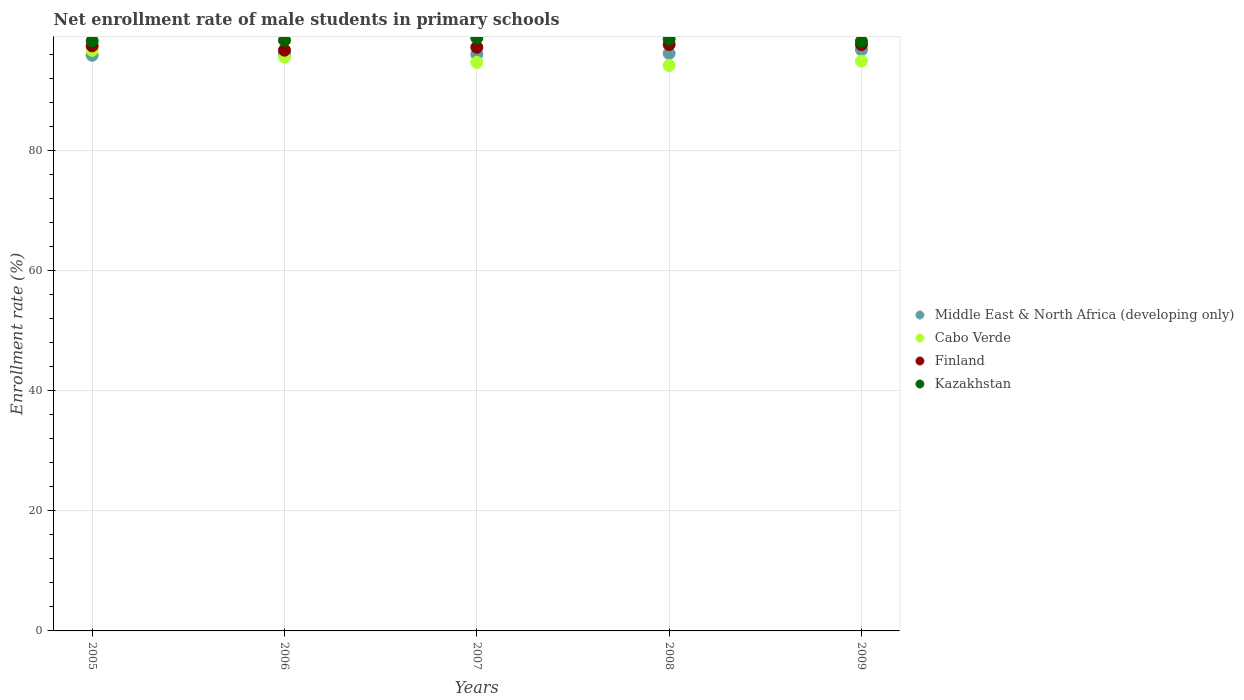What is the net enrollment rate of male students in primary schools in Finland in 2009?
Offer a terse response. 97.64. Across all years, what is the maximum net enrollment rate of male students in primary schools in Kazakhstan?
Your answer should be very brief. 98.74. Across all years, what is the minimum net enrollment rate of male students in primary schools in Kazakhstan?
Make the answer very short. 98.2. What is the total net enrollment rate of male students in primary schools in Cabo Verde in the graph?
Keep it short and to the point. 475.93. What is the difference between the net enrollment rate of male students in primary schools in Kazakhstan in 2006 and that in 2008?
Your response must be concise. -0.2. What is the difference between the net enrollment rate of male students in primary schools in Cabo Verde in 2008 and the net enrollment rate of male students in primary schools in Middle East & North Africa (developing only) in 2007?
Your response must be concise. -1.85. What is the average net enrollment rate of male students in primary schools in Finland per year?
Ensure brevity in your answer.  97.32. In the year 2007, what is the difference between the net enrollment rate of male students in primary schools in Middle East & North Africa (developing only) and net enrollment rate of male students in primary schools in Finland?
Your answer should be very brief. -1.18. In how many years, is the net enrollment rate of male students in primary schools in Cabo Verde greater than 40 %?
Your answer should be very brief. 5. What is the ratio of the net enrollment rate of male students in primary schools in Finland in 2008 to that in 2009?
Give a very brief answer. 1. What is the difference between the highest and the second highest net enrollment rate of male students in primary schools in Kazakhstan?
Provide a short and direct response. 0.19. What is the difference between the highest and the lowest net enrollment rate of male students in primary schools in Cabo Verde?
Offer a very short reply. 2.53. Is it the case that in every year, the sum of the net enrollment rate of male students in primary schools in Cabo Verde and net enrollment rate of male students in primary schools in Middle East & North Africa (developing only)  is greater than the sum of net enrollment rate of male students in primary schools in Finland and net enrollment rate of male students in primary schools in Kazakhstan?
Your response must be concise. No. Is the net enrollment rate of male students in primary schools in Kazakhstan strictly greater than the net enrollment rate of male students in primary schools in Finland over the years?
Provide a succinct answer. Yes. How many years are there in the graph?
Ensure brevity in your answer.  5. Are the values on the major ticks of Y-axis written in scientific E-notation?
Make the answer very short. No. Does the graph contain any zero values?
Your response must be concise. No. Does the graph contain grids?
Offer a terse response. Yes. What is the title of the graph?
Ensure brevity in your answer.  Net enrollment rate of male students in primary schools. Does "Lao PDR" appear as one of the legend labels in the graph?
Your answer should be compact. No. What is the label or title of the X-axis?
Offer a terse response. Years. What is the label or title of the Y-axis?
Your response must be concise. Enrollment rate (%). What is the Enrollment rate (%) of Middle East & North Africa (developing only) in 2005?
Your answer should be compact. 95.85. What is the Enrollment rate (%) in Cabo Verde in 2005?
Make the answer very short. 96.68. What is the Enrollment rate (%) in Finland in 2005?
Offer a very short reply. 97.43. What is the Enrollment rate (%) of Kazakhstan in 2005?
Offer a terse response. 98.26. What is the Enrollment rate (%) of Middle East & North Africa (developing only) in 2006?
Provide a short and direct response. 96.03. What is the Enrollment rate (%) in Cabo Verde in 2006?
Your answer should be very brief. 95.53. What is the Enrollment rate (%) of Finland in 2006?
Make the answer very short. 96.71. What is the Enrollment rate (%) in Kazakhstan in 2006?
Your answer should be very brief. 98.36. What is the Enrollment rate (%) of Middle East & North Africa (developing only) in 2007?
Make the answer very short. 96. What is the Enrollment rate (%) in Cabo Verde in 2007?
Offer a very short reply. 94.67. What is the Enrollment rate (%) of Finland in 2007?
Offer a very short reply. 97.19. What is the Enrollment rate (%) of Kazakhstan in 2007?
Give a very brief answer. 98.74. What is the Enrollment rate (%) of Middle East & North Africa (developing only) in 2008?
Keep it short and to the point. 96.17. What is the Enrollment rate (%) of Cabo Verde in 2008?
Offer a terse response. 94.15. What is the Enrollment rate (%) in Finland in 2008?
Provide a short and direct response. 97.65. What is the Enrollment rate (%) in Kazakhstan in 2008?
Make the answer very short. 98.56. What is the Enrollment rate (%) of Middle East & North Africa (developing only) in 2009?
Offer a terse response. 96.76. What is the Enrollment rate (%) of Cabo Verde in 2009?
Your answer should be compact. 94.89. What is the Enrollment rate (%) in Finland in 2009?
Give a very brief answer. 97.64. What is the Enrollment rate (%) in Kazakhstan in 2009?
Offer a terse response. 98.2. Across all years, what is the maximum Enrollment rate (%) in Middle East & North Africa (developing only)?
Your answer should be compact. 96.76. Across all years, what is the maximum Enrollment rate (%) in Cabo Verde?
Your response must be concise. 96.68. Across all years, what is the maximum Enrollment rate (%) in Finland?
Keep it short and to the point. 97.65. Across all years, what is the maximum Enrollment rate (%) of Kazakhstan?
Offer a terse response. 98.74. Across all years, what is the minimum Enrollment rate (%) in Middle East & North Africa (developing only)?
Your answer should be compact. 95.85. Across all years, what is the minimum Enrollment rate (%) of Cabo Verde?
Your answer should be very brief. 94.15. Across all years, what is the minimum Enrollment rate (%) of Finland?
Provide a succinct answer. 96.71. Across all years, what is the minimum Enrollment rate (%) of Kazakhstan?
Your answer should be very brief. 98.2. What is the total Enrollment rate (%) in Middle East & North Africa (developing only) in the graph?
Your answer should be compact. 480.81. What is the total Enrollment rate (%) in Cabo Verde in the graph?
Keep it short and to the point. 475.93. What is the total Enrollment rate (%) of Finland in the graph?
Offer a very short reply. 486.61. What is the total Enrollment rate (%) of Kazakhstan in the graph?
Your answer should be very brief. 492.12. What is the difference between the Enrollment rate (%) in Middle East & North Africa (developing only) in 2005 and that in 2006?
Provide a succinct answer. -0.17. What is the difference between the Enrollment rate (%) in Cabo Verde in 2005 and that in 2006?
Provide a short and direct response. 1.15. What is the difference between the Enrollment rate (%) in Finland in 2005 and that in 2006?
Make the answer very short. 0.72. What is the difference between the Enrollment rate (%) of Kazakhstan in 2005 and that in 2006?
Offer a terse response. -0.1. What is the difference between the Enrollment rate (%) of Middle East & North Africa (developing only) in 2005 and that in 2007?
Your answer should be very brief. -0.15. What is the difference between the Enrollment rate (%) of Cabo Verde in 2005 and that in 2007?
Offer a very short reply. 2.01. What is the difference between the Enrollment rate (%) of Finland in 2005 and that in 2007?
Give a very brief answer. 0.24. What is the difference between the Enrollment rate (%) of Kazakhstan in 2005 and that in 2007?
Your answer should be compact. -0.48. What is the difference between the Enrollment rate (%) of Middle East & North Africa (developing only) in 2005 and that in 2008?
Offer a terse response. -0.31. What is the difference between the Enrollment rate (%) of Cabo Verde in 2005 and that in 2008?
Offer a terse response. 2.53. What is the difference between the Enrollment rate (%) in Finland in 2005 and that in 2008?
Make the answer very short. -0.22. What is the difference between the Enrollment rate (%) of Kazakhstan in 2005 and that in 2008?
Your response must be concise. -0.3. What is the difference between the Enrollment rate (%) in Middle East & North Africa (developing only) in 2005 and that in 2009?
Your answer should be very brief. -0.91. What is the difference between the Enrollment rate (%) in Cabo Verde in 2005 and that in 2009?
Ensure brevity in your answer.  1.79. What is the difference between the Enrollment rate (%) in Finland in 2005 and that in 2009?
Keep it short and to the point. -0.21. What is the difference between the Enrollment rate (%) of Kazakhstan in 2005 and that in 2009?
Offer a terse response. 0.06. What is the difference between the Enrollment rate (%) of Middle East & North Africa (developing only) in 2006 and that in 2007?
Ensure brevity in your answer.  0.02. What is the difference between the Enrollment rate (%) of Cabo Verde in 2006 and that in 2007?
Make the answer very short. 0.86. What is the difference between the Enrollment rate (%) of Finland in 2006 and that in 2007?
Your answer should be very brief. -0.48. What is the difference between the Enrollment rate (%) in Kazakhstan in 2006 and that in 2007?
Offer a terse response. -0.38. What is the difference between the Enrollment rate (%) in Middle East & North Africa (developing only) in 2006 and that in 2008?
Your answer should be very brief. -0.14. What is the difference between the Enrollment rate (%) in Cabo Verde in 2006 and that in 2008?
Offer a very short reply. 1.38. What is the difference between the Enrollment rate (%) of Finland in 2006 and that in 2008?
Give a very brief answer. -0.94. What is the difference between the Enrollment rate (%) of Kazakhstan in 2006 and that in 2008?
Ensure brevity in your answer.  -0.2. What is the difference between the Enrollment rate (%) in Middle East & North Africa (developing only) in 2006 and that in 2009?
Offer a very short reply. -0.73. What is the difference between the Enrollment rate (%) of Cabo Verde in 2006 and that in 2009?
Provide a succinct answer. 0.64. What is the difference between the Enrollment rate (%) in Finland in 2006 and that in 2009?
Your answer should be very brief. -0.93. What is the difference between the Enrollment rate (%) of Kazakhstan in 2006 and that in 2009?
Your answer should be compact. 0.16. What is the difference between the Enrollment rate (%) in Middle East & North Africa (developing only) in 2007 and that in 2008?
Offer a terse response. -0.16. What is the difference between the Enrollment rate (%) in Cabo Verde in 2007 and that in 2008?
Offer a terse response. 0.52. What is the difference between the Enrollment rate (%) of Finland in 2007 and that in 2008?
Your response must be concise. -0.47. What is the difference between the Enrollment rate (%) in Kazakhstan in 2007 and that in 2008?
Your response must be concise. 0.19. What is the difference between the Enrollment rate (%) of Middle East & North Africa (developing only) in 2007 and that in 2009?
Your answer should be very brief. -0.76. What is the difference between the Enrollment rate (%) of Cabo Verde in 2007 and that in 2009?
Make the answer very short. -0.22. What is the difference between the Enrollment rate (%) in Finland in 2007 and that in 2009?
Offer a terse response. -0.45. What is the difference between the Enrollment rate (%) of Kazakhstan in 2007 and that in 2009?
Give a very brief answer. 0.54. What is the difference between the Enrollment rate (%) in Middle East & North Africa (developing only) in 2008 and that in 2009?
Provide a succinct answer. -0.59. What is the difference between the Enrollment rate (%) of Cabo Verde in 2008 and that in 2009?
Ensure brevity in your answer.  -0.74. What is the difference between the Enrollment rate (%) in Finland in 2008 and that in 2009?
Provide a short and direct response. 0.01. What is the difference between the Enrollment rate (%) of Kazakhstan in 2008 and that in 2009?
Offer a very short reply. 0.36. What is the difference between the Enrollment rate (%) in Middle East & North Africa (developing only) in 2005 and the Enrollment rate (%) in Cabo Verde in 2006?
Provide a succinct answer. 0.32. What is the difference between the Enrollment rate (%) in Middle East & North Africa (developing only) in 2005 and the Enrollment rate (%) in Finland in 2006?
Provide a short and direct response. -0.86. What is the difference between the Enrollment rate (%) in Middle East & North Africa (developing only) in 2005 and the Enrollment rate (%) in Kazakhstan in 2006?
Your response must be concise. -2.51. What is the difference between the Enrollment rate (%) of Cabo Verde in 2005 and the Enrollment rate (%) of Finland in 2006?
Offer a terse response. -0.03. What is the difference between the Enrollment rate (%) of Cabo Verde in 2005 and the Enrollment rate (%) of Kazakhstan in 2006?
Give a very brief answer. -1.68. What is the difference between the Enrollment rate (%) of Finland in 2005 and the Enrollment rate (%) of Kazakhstan in 2006?
Your response must be concise. -0.93. What is the difference between the Enrollment rate (%) in Middle East & North Africa (developing only) in 2005 and the Enrollment rate (%) in Cabo Verde in 2007?
Your response must be concise. 1.18. What is the difference between the Enrollment rate (%) in Middle East & North Africa (developing only) in 2005 and the Enrollment rate (%) in Finland in 2007?
Your answer should be very brief. -1.33. What is the difference between the Enrollment rate (%) in Middle East & North Africa (developing only) in 2005 and the Enrollment rate (%) in Kazakhstan in 2007?
Provide a short and direct response. -2.89. What is the difference between the Enrollment rate (%) in Cabo Verde in 2005 and the Enrollment rate (%) in Finland in 2007?
Provide a succinct answer. -0.5. What is the difference between the Enrollment rate (%) of Cabo Verde in 2005 and the Enrollment rate (%) of Kazakhstan in 2007?
Offer a terse response. -2.06. What is the difference between the Enrollment rate (%) of Finland in 2005 and the Enrollment rate (%) of Kazakhstan in 2007?
Make the answer very short. -1.31. What is the difference between the Enrollment rate (%) in Middle East & North Africa (developing only) in 2005 and the Enrollment rate (%) in Cabo Verde in 2008?
Ensure brevity in your answer.  1.7. What is the difference between the Enrollment rate (%) in Middle East & North Africa (developing only) in 2005 and the Enrollment rate (%) in Finland in 2008?
Offer a terse response. -1.8. What is the difference between the Enrollment rate (%) of Middle East & North Africa (developing only) in 2005 and the Enrollment rate (%) of Kazakhstan in 2008?
Ensure brevity in your answer.  -2.7. What is the difference between the Enrollment rate (%) in Cabo Verde in 2005 and the Enrollment rate (%) in Finland in 2008?
Provide a short and direct response. -0.97. What is the difference between the Enrollment rate (%) of Cabo Verde in 2005 and the Enrollment rate (%) of Kazakhstan in 2008?
Offer a terse response. -1.88. What is the difference between the Enrollment rate (%) of Finland in 2005 and the Enrollment rate (%) of Kazakhstan in 2008?
Ensure brevity in your answer.  -1.13. What is the difference between the Enrollment rate (%) of Middle East & North Africa (developing only) in 2005 and the Enrollment rate (%) of Cabo Verde in 2009?
Give a very brief answer. 0.96. What is the difference between the Enrollment rate (%) of Middle East & North Africa (developing only) in 2005 and the Enrollment rate (%) of Finland in 2009?
Your answer should be compact. -1.78. What is the difference between the Enrollment rate (%) in Middle East & North Africa (developing only) in 2005 and the Enrollment rate (%) in Kazakhstan in 2009?
Your answer should be compact. -2.35. What is the difference between the Enrollment rate (%) of Cabo Verde in 2005 and the Enrollment rate (%) of Finland in 2009?
Your answer should be very brief. -0.96. What is the difference between the Enrollment rate (%) of Cabo Verde in 2005 and the Enrollment rate (%) of Kazakhstan in 2009?
Keep it short and to the point. -1.52. What is the difference between the Enrollment rate (%) of Finland in 2005 and the Enrollment rate (%) of Kazakhstan in 2009?
Ensure brevity in your answer.  -0.77. What is the difference between the Enrollment rate (%) of Middle East & North Africa (developing only) in 2006 and the Enrollment rate (%) of Cabo Verde in 2007?
Give a very brief answer. 1.36. What is the difference between the Enrollment rate (%) of Middle East & North Africa (developing only) in 2006 and the Enrollment rate (%) of Finland in 2007?
Keep it short and to the point. -1.16. What is the difference between the Enrollment rate (%) in Middle East & North Africa (developing only) in 2006 and the Enrollment rate (%) in Kazakhstan in 2007?
Your answer should be very brief. -2.72. What is the difference between the Enrollment rate (%) in Cabo Verde in 2006 and the Enrollment rate (%) in Finland in 2007?
Your answer should be compact. -1.65. What is the difference between the Enrollment rate (%) of Cabo Verde in 2006 and the Enrollment rate (%) of Kazakhstan in 2007?
Ensure brevity in your answer.  -3.21. What is the difference between the Enrollment rate (%) of Finland in 2006 and the Enrollment rate (%) of Kazakhstan in 2007?
Your response must be concise. -2.03. What is the difference between the Enrollment rate (%) of Middle East & North Africa (developing only) in 2006 and the Enrollment rate (%) of Cabo Verde in 2008?
Offer a very short reply. 1.87. What is the difference between the Enrollment rate (%) of Middle East & North Africa (developing only) in 2006 and the Enrollment rate (%) of Finland in 2008?
Give a very brief answer. -1.62. What is the difference between the Enrollment rate (%) in Middle East & North Africa (developing only) in 2006 and the Enrollment rate (%) in Kazakhstan in 2008?
Give a very brief answer. -2.53. What is the difference between the Enrollment rate (%) in Cabo Verde in 2006 and the Enrollment rate (%) in Finland in 2008?
Give a very brief answer. -2.12. What is the difference between the Enrollment rate (%) in Cabo Verde in 2006 and the Enrollment rate (%) in Kazakhstan in 2008?
Your answer should be very brief. -3.02. What is the difference between the Enrollment rate (%) in Finland in 2006 and the Enrollment rate (%) in Kazakhstan in 2008?
Keep it short and to the point. -1.85. What is the difference between the Enrollment rate (%) of Middle East & North Africa (developing only) in 2006 and the Enrollment rate (%) of Cabo Verde in 2009?
Provide a succinct answer. 1.14. What is the difference between the Enrollment rate (%) of Middle East & North Africa (developing only) in 2006 and the Enrollment rate (%) of Finland in 2009?
Ensure brevity in your answer.  -1.61. What is the difference between the Enrollment rate (%) of Middle East & North Africa (developing only) in 2006 and the Enrollment rate (%) of Kazakhstan in 2009?
Provide a short and direct response. -2.17. What is the difference between the Enrollment rate (%) in Cabo Verde in 2006 and the Enrollment rate (%) in Finland in 2009?
Offer a very short reply. -2.1. What is the difference between the Enrollment rate (%) of Cabo Verde in 2006 and the Enrollment rate (%) of Kazakhstan in 2009?
Your answer should be compact. -2.67. What is the difference between the Enrollment rate (%) of Finland in 2006 and the Enrollment rate (%) of Kazakhstan in 2009?
Offer a very short reply. -1.49. What is the difference between the Enrollment rate (%) of Middle East & North Africa (developing only) in 2007 and the Enrollment rate (%) of Cabo Verde in 2008?
Keep it short and to the point. 1.85. What is the difference between the Enrollment rate (%) in Middle East & North Africa (developing only) in 2007 and the Enrollment rate (%) in Finland in 2008?
Provide a succinct answer. -1.65. What is the difference between the Enrollment rate (%) in Middle East & North Africa (developing only) in 2007 and the Enrollment rate (%) in Kazakhstan in 2008?
Make the answer very short. -2.55. What is the difference between the Enrollment rate (%) of Cabo Verde in 2007 and the Enrollment rate (%) of Finland in 2008?
Your response must be concise. -2.98. What is the difference between the Enrollment rate (%) of Cabo Verde in 2007 and the Enrollment rate (%) of Kazakhstan in 2008?
Your answer should be compact. -3.89. What is the difference between the Enrollment rate (%) of Finland in 2007 and the Enrollment rate (%) of Kazakhstan in 2008?
Your answer should be compact. -1.37. What is the difference between the Enrollment rate (%) in Middle East & North Africa (developing only) in 2007 and the Enrollment rate (%) in Cabo Verde in 2009?
Ensure brevity in your answer.  1.11. What is the difference between the Enrollment rate (%) of Middle East & North Africa (developing only) in 2007 and the Enrollment rate (%) of Finland in 2009?
Your response must be concise. -1.63. What is the difference between the Enrollment rate (%) of Middle East & North Africa (developing only) in 2007 and the Enrollment rate (%) of Kazakhstan in 2009?
Your answer should be very brief. -2.2. What is the difference between the Enrollment rate (%) in Cabo Verde in 2007 and the Enrollment rate (%) in Finland in 2009?
Offer a terse response. -2.97. What is the difference between the Enrollment rate (%) of Cabo Verde in 2007 and the Enrollment rate (%) of Kazakhstan in 2009?
Your response must be concise. -3.53. What is the difference between the Enrollment rate (%) of Finland in 2007 and the Enrollment rate (%) of Kazakhstan in 2009?
Make the answer very short. -1.01. What is the difference between the Enrollment rate (%) in Middle East & North Africa (developing only) in 2008 and the Enrollment rate (%) in Cabo Verde in 2009?
Provide a succinct answer. 1.28. What is the difference between the Enrollment rate (%) of Middle East & North Africa (developing only) in 2008 and the Enrollment rate (%) of Finland in 2009?
Ensure brevity in your answer.  -1.47. What is the difference between the Enrollment rate (%) in Middle East & North Africa (developing only) in 2008 and the Enrollment rate (%) in Kazakhstan in 2009?
Offer a terse response. -2.03. What is the difference between the Enrollment rate (%) of Cabo Verde in 2008 and the Enrollment rate (%) of Finland in 2009?
Keep it short and to the point. -3.48. What is the difference between the Enrollment rate (%) of Cabo Verde in 2008 and the Enrollment rate (%) of Kazakhstan in 2009?
Provide a succinct answer. -4.04. What is the difference between the Enrollment rate (%) in Finland in 2008 and the Enrollment rate (%) in Kazakhstan in 2009?
Keep it short and to the point. -0.55. What is the average Enrollment rate (%) in Middle East & North Africa (developing only) per year?
Provide a succinct answer. 96.16. What is the average Enrollment rate (%) in Cabo Verde per year?
Offer a terse response. 95.19. What is the average Enrollment rate (%) of Finland per year?
Your answer should be very brief. 97.32. What is the average Enrollment rate (%) in Kazakhstan per year?
Your answer should be very brief. 98.42. In the year 2005, what is the difference between the Enrollment rate (%) of Middle East & North Africa (developing only) and Enrollment rate (%) of Cabo Verde?
Your response must be concise. -0.83. In the year 2005, what is the difference between the Enrollment rate (%) of Middle East & North Africa (developing only) and Enrollment rate (%) of Finland?
Your answer should be very brief. -1.57. In the year 2005, what is the difference between the Enrollment rate (%) in Middle East & North Africa (developing only) and Enrollment rate (%) in Kazakhstan?
Offer a terse response. -2.41. In the year 2005, what is the difference between the Enrollment rate (%) in Cabo Verde and Enrollment rate (%) in Finland?
Offer a terse response. -0.75. In the year 2005, what is the difference between the Enrollment rate (%) of Cabo Verde and Enrollment rate (%) of Kazakhstan?
Provide a short and direct response. -1.58. In the year 2005, what is the difference between the Enrollment rate (%) of Finland and Enrollment rate (%) of Kazakhstan?
Your answer should be very brief. -0.83. In the year 2006, what is the difference between the Enrollment rate (%) of Middle East & North Africa (developing only) and Enrollment rate (%) of Cabo Verde?
Your response must be concise. 0.49. In the year 2006, what is the difference between the Enrollment rate (%) of Middle East & North Africa (developing only) and Enrollment rate (%) of Finland?
Keep it short and to the point. -0.68. In the year 2006, what is the difference between the Enrollment rate (%) in Middle East & North Africa (developing only) and Enrollment rate (%) in Kazakhstan?
Your response must be concise. -2.33. In the year 2006, what is the difference between the Enrollment rate (%) in Cabo Verde and Enrollment rate (%) in Finland?
Your answer should be compact. -1.18. In the year 2006, what is the difference between the Enrollment rate (%) in Cabo Verde and Enrollment rate (%) in Kazakhstan?
Your answer should be very brief. -2.83. In the year 2006, what is the difference between the Enrollment rate (%) of Finland and Enrollment rate (%) of Kazakhstan?
Provide a short and direct response. -1.65. In the year 2007, what is the difference between the Enrollment rate (%) of Middle East & North Africa (developing only) and Enrollment rate (%) of Cabo Verde?
Ensure brevity in your answer.  1.33. In the year 2007, what is the difference between the Enrollment rate (%) of Middle East & North Africa (developing only) and Enrollment rate (%) of Finland?
Make the answer very short. -1.18. In the year 2007, what is the difference between the Enrollment rate (%) in Middle East & North Africa (developing only) and Enrollment rate (%) in Kazakhstan?
Your response must be concise. -2.74. In the year 2007, what is the difference between the Enrollment rate (%) in Cabo Verde and Enrollment rate (%) in Finland?
Ensure brevity in your answer.  -2.51. In the year 2007, what is the difference between the Enrollment rate (%) of Cabo Verde and Enrollment rate (%) of Kazakhstan?
Keep it short and to the point. -4.07. In the year 2007, what is the difference between the Enrollment rate (%) in Finland and Enrollment rate (%) in Kazakhstan?
Your answer should be compact. -1.56. In the year 2008, what is the difference between the Enrollment rate (%) in Middle East & North Africa (developing only) and Enrollment rate (%) in Cabo Verde?
Your answer should be compact. 2.01. In the year 2008, what is the difference between the Enrollment rate (%) in Middle East & North Africa (developing only) and Enrollment rate (%) in Finland?
Keep it short and to the point. -1.48. In the year 2008, what is the difference between the Enrollment rate (%) in Middle East & North Africa (developing only) and Enrollment rate (%) in Kazakhstan?
Your answer should be very brief. -2.39. In the year 2008, what is the difference between the Enrollment rate (%) in Cabo Verde and Enrollment rate (%) in Finland?
Provide a short and direct response. -3.5. In the year 2008, what is the difference between the Enrollment rate (%) in Cabo Verde and Enrollment rate (%) in Kazakhstan?
Offer a very short reply. -4.4. In the year 2008, what is the difference between the Enrollment rate (%) in Finland and Enrollment rate (%) in Kazakhstan?
Give a very brief answer. -0.91. In the year 2009, what is the difference between the Enrollment rate (%) of Middle East & North Africa (developing only) and Enrollment rate (%) of Cabo Verde?
Provide a short and direct response. 1.87. In the year 2009, what is the difference between the Enrollment rate (%) in Middle East & North Africa (developing only) and Enrollment rate (%) in Finland?
Ensure brevity in your answer.  -0.88. In the year 2009, what is the difference between the Enrollment rate (%) in Middle East & North Africa (developing only) and Enrollment rate (%) in Kazakhstan?
Ensure brevity in your answer.  -1.44. In the year 2009, what is the difference between the Enrollment rate (%) in Cabo Verde and Enrollment rate (%) in Finland?
Offer a very short reply. -2.75. In the year 2009, what is the difference between the Enrollment rate (%) of Cabo Verde and Enrollment rate (%) of Kazakhstan?
Provide a short and direct response. -3.31. In the year 2009, what is the difference between the Enrollment rate (%) of Finland and Enrollment rate (%) of Kazakhstan?
Keep it short and to the point. -0.56. What is the ratio of the Enrollment rate (%) in Middle East & North Africa (developing only) in 2005 to that in 2006?
Provide a succinct answer. 1. What is the ratio of the Enrollment rate (%) in Cabo Verde in 2005 to that in 2006?
Offer a very short reply. 1.01. What is the ratio of the Enrollment rate (%) of Finland in 2005 to that in 2006?
Your answer should be very brief. 1.01. What is the ratio of the Enrollment rate (%) of Middle East & North Africa (developing only) in 2005 to that in 2007?
Offer a very short reply. 1. What is the ratio of the Enrollment rate (%) in Cabo Verde in 2005 to that in 2007?
Provide a succinct answer. 1.02. What is the ratio of the Enrollment rate (%) of Middle East & North Africa (developing only) in 2005 to that in 2008?
Your response must be concise. 1. What is the ratio of the Enrollment rate (%) in Cabo Verde in 2005 to that in 2008?
Your response must be concise. 1.03. What is the ratio of the Enrollment rate (%) of Finland in 2005 to that in 2008?
Your answer should be compact. 1. What is the ratio of the Enrollment rate (%) in Kazakhstan in 2005 to that in 2008?
Make the answer very short. 1. What is the ratio of the Enrollment rate (%) in Middle East & North Africa (developing only) in 2005 to that in 2009?
Keep it short and to the point. 0.99. What is the ratio of the Enrollment rate (%) of Cabo Verde in 2005 to that in 2009?
Ensure brevity in your answer.  1.02. What is the ratio of the Enrollment rate (%) in Kazakhstan in 2005 to that in 2009?
Give a very brief answer. 1. What is the ratio of the Enrollment rate (%) in Cabo Verde in 2006 to that in 2007?
Give a very brief answer. 1.01. What is the ratio of the Enrollment rate (%) in Kazakhstan in 2006 to that in 2007?
Ensure brevity in your answer.  1. What is the ratio of the Enrollment rate (%) in Middle East & North Africa (developing only) in 2006 to that in 2008?
Your response must be concise. 1. What is the ratio of the Enrollment rate (%) of Cabo Verde in 2006 to that in 2008?
Your answer should be very brief. 1.01. What is the ratio of the Enrollment rate (%) of Finland in 2006 to that in 2008?
Give a very brief answer. 0.99. What is the ratio of the Enrollment rate (%) in Middle East & North Africa (developing only) in 2006 to that in 2009?
Keep it short and to the point. 0.99. What is the ratio of the Enrollment rate (%) in Cabo Verde in 2006 to that in 2009?
Give a very brief answer. 1.01. What is the ratio of the Enrollment rate (%) in Finland in 2006 to that in 2009?
Offer a terse response. 0.99. What is the ratio of the Enrollment rate (%) of Kazakhstan in 2006 to that in 2009?
Your answer should be compact. 1. What is the ratio of the Enrollment rate (%) in Middle East & North Africa (developing only) in 2007 to that in 2008?
Give a very brief answer. 1. What is the ratio of the Enrollment rate (%) of Cabo Verde in 2007 to that in 2008?
Ensure brevity in your answer.  1.01. What is the ratio of the Enrollment rate (%) in Finland in 2007 to that in 2008?
Your response must be concise. 1. What is the ratio of the Enrollment rate (%) in Kazakhstan in 2007 to that in 2008?
Make the answer very short. 1. What is the ratio of the Enrollment rate (%) in Finland in 2007 to that in 2009?
Ensure brevity in your answer.  1. What is the ratio of the Enrollment rate (%) in Kazakhstan in 2007 to that in 2009?
Offer a terse response. 1.01. What is the ratio of the Enrollment rate (%) of Middle East & North Africa (developing only) in 2008 to that in 2009?
Make the answer very short. 0.99. What is the ratio of the Enrollment rate (%) in Finland in 2008 to that in 2009?
Your response must be concise. 1. What is the difference between the highest and the second highest Enrollment rate (%) of Middle East & North Africa (developing only)?
Offer a very short reply. 0.59. What is the difference between the highest and the second highest Enrollment rate (%) in Cabo Verde?
Your answer should be very brief. 1.15. What is the difference between the highest and the second highest Enrollment rate (%) in Finland?
Keep it short and to the point. 0.01. What is the difference between the highest and the second highest Enrollment rate (%) of Kazakhstan?
Keep it short and to the point. 0.19. What is the difference between the highest and the lowest Enrollment rate (%) in Middle East & North Africa (developing only)?
Your answer should be very brief. 0.91. What is the difference between the highest and the lowest Enrollment rate (%) in Cabo Verde?
Provide a succinct answer. 2.53. What is the difference between the highest and the lowest Enrollment rate (%) in Finland?
Offer a terse response. 0.94. What is the difference between the highest and the lowest Enrollment rate (%) of Kazakhstan?
Provide a succinct answer. 0.54. 